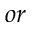<formula> <loc_0><loc_0><loc_500><loc_500>o r</formula> 